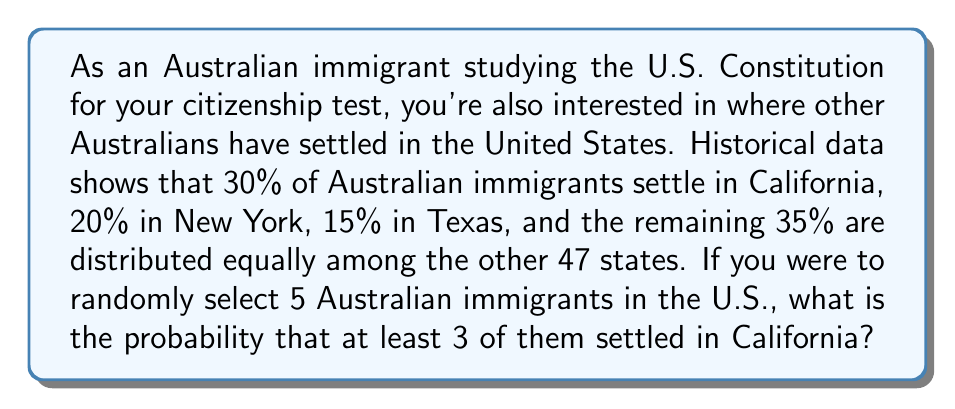Solve this math problem. Let's approach this step-by-step using the binomial probability distribution:

1) We can model this as a binomial experiment where:
   - $n = 5$ (number of trials/immigrants selected)
   - $p = 0.30$ (probability of an immigrant settling in California)
   - We want $P(X \geq 3)$, where $X$ is the number of immigrants who settled in California

2) We can calculate this as:
   $P(X \geq 3) = P(X = 3) + P(X = 4) + P(X = 5)$

3) The binomial probability formula is:
   $P(X = k) = \binom{n}{k} p^k (1-p)^{n-k}$

4) Let's calculate each probability:

   $P(X = 3) = \binom{5}{3} (0.30)^3 (0.70)^2$
              $= 10 \times 0.027 \times 0.49 = 0.1323$

   $P(X = 4) = \binom{5}{4} (0.30)^4 (0.70)^1$
              $= 5 \times 0.0081 \times 0.70 = 0.02835$

   $P(X = 5) = \binom{5}{5} (0.30)^5 (0.70)^0$
              $= 1 \times 0.00243 \times 1 = 0.00243$

5) Now, we sum these probabilities:
   $P(X \geq 3) = 0.1323 + 0.02835 + 0.00243 = 0.16308$

Therefore, the probability that at least 3 out of 5 randomly selected Australian immigrants settled in California is approximately 0.16308 or 16.31%.
Answer: 0.16308 or 16.31% 